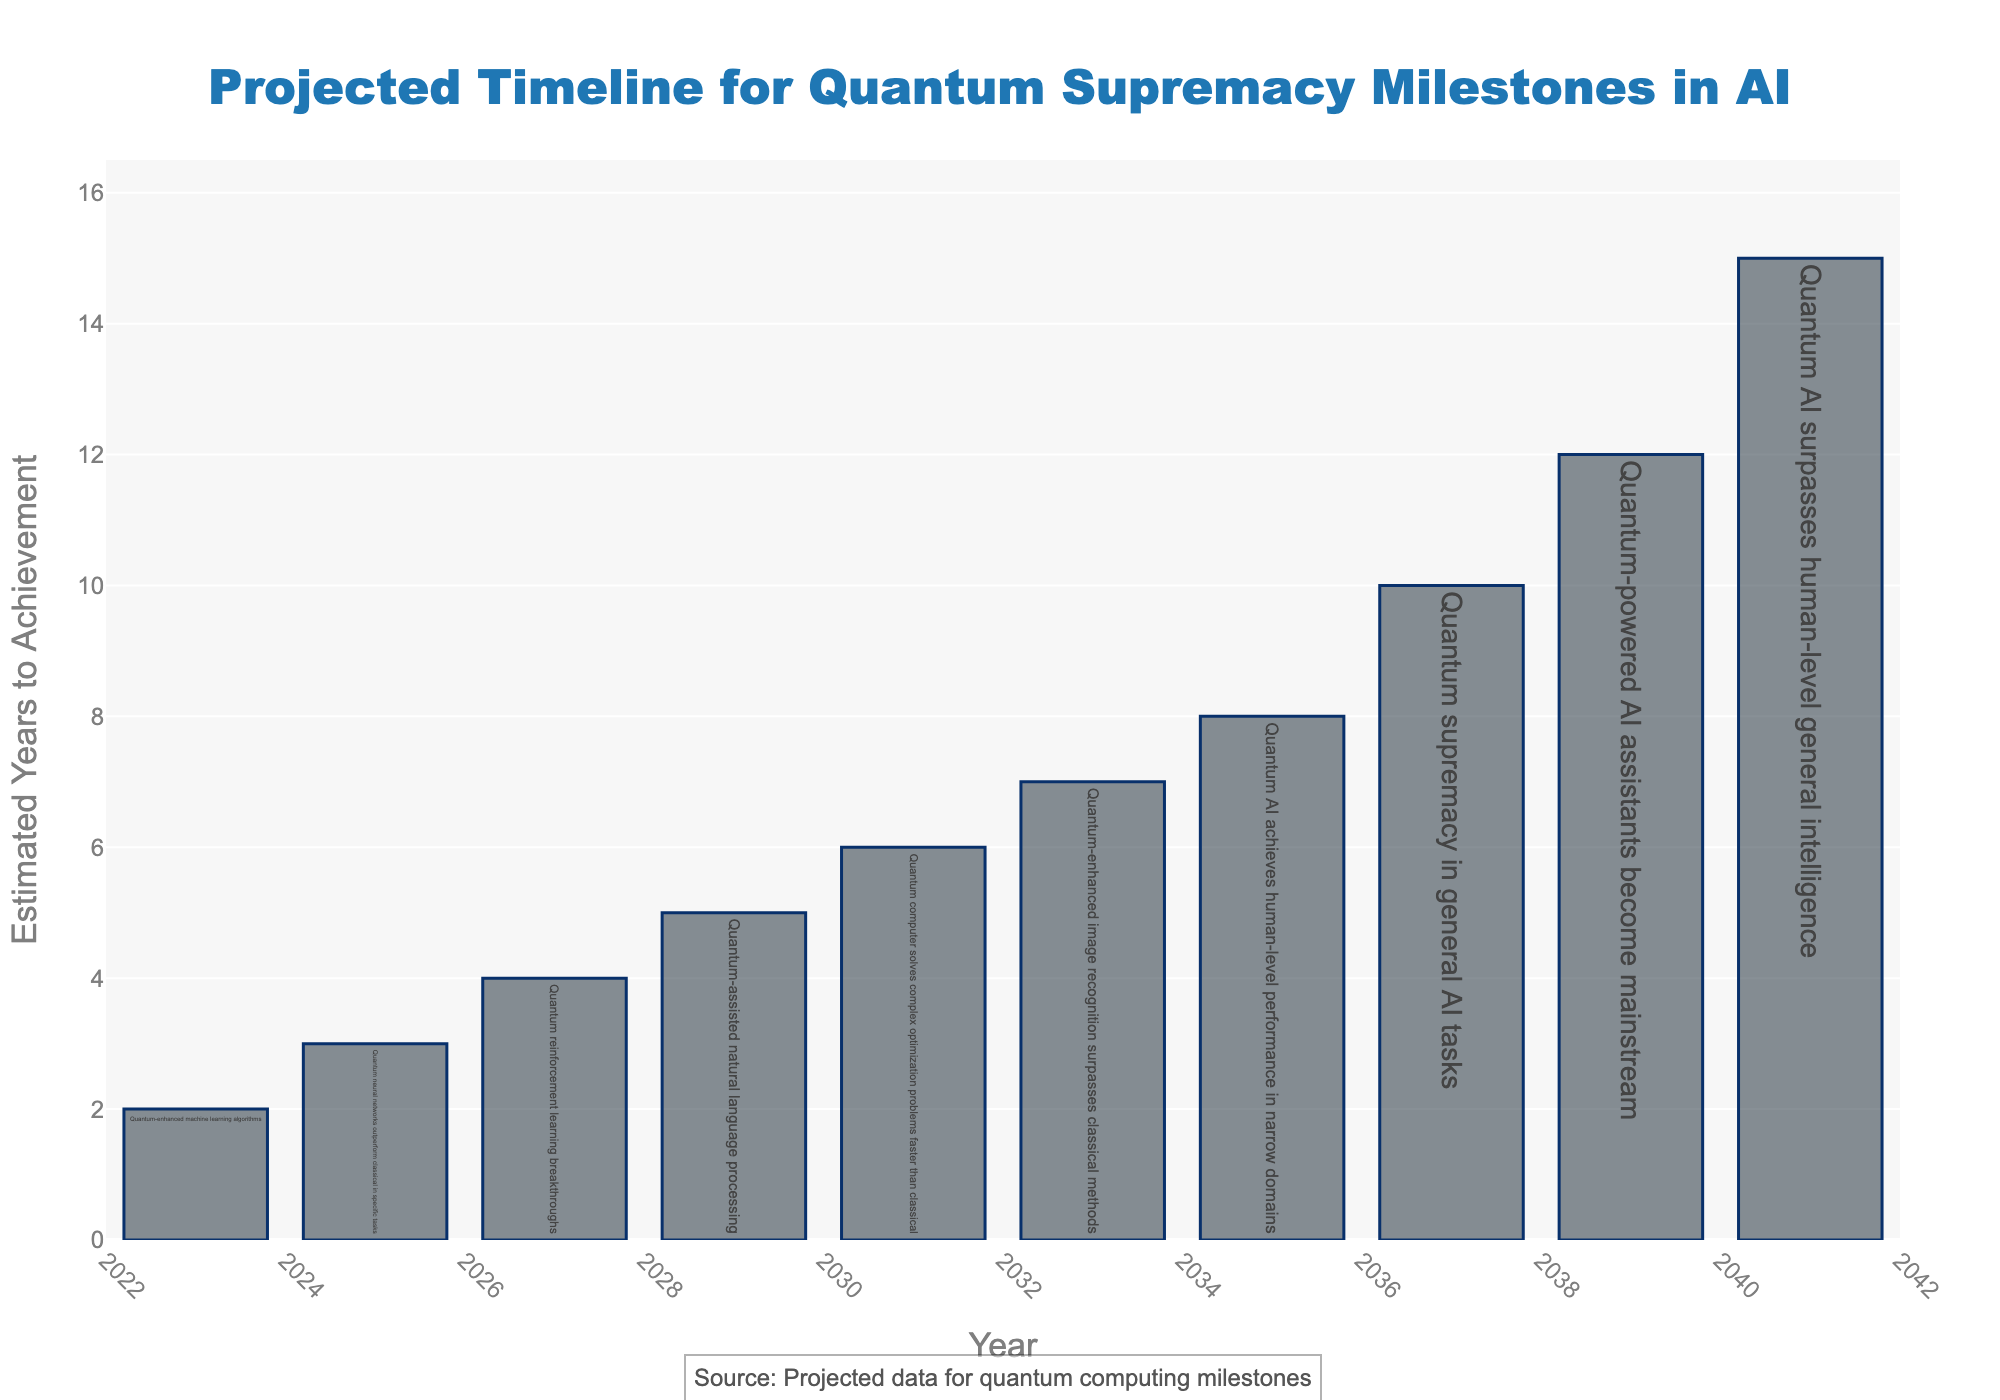What milestone is projected to be achieved by 2025? The bar corresponding to the year 2025 lists "Quantum neural networks outperform classical in specific tasks" as the milestone. This is confirmed by the hover text that provides detailed information.
Answer: Quantum neural networks outperform classical in specific tasks Which milestone takes the longest time to achieve from the start year? The bars represent different milestones, and the last one for the year 2041 lists "Quantum AI surpasses human-level general intelligence" with 15 estimated years. This is the highest number of years among all milestones.
Answer: Quantum AI surpasses human-level general intelligence What is the total estimated years to achievement for milestones projected between 2025 and 2031? To find the total, we add the estimated years for the milestones in 2025 (3 years), 2027 (4 years), and 2029 (5 years). This gives 3 + 4 + 5 = 12 years.
Answer: 12 years How does the estimated time to achieve "Quantum-enhanced image recognition surpasses classical methods" compare to "Quantum-assisted natural language processing"? The milestone for "Quantum-enhanced image recognition surpasses classical methods" is projected at 2033 with 7 years, while "Quantum-assisted natural language processing" is projected at 2029 with 5 years. 7 is greater than 5.
Answer: Quantum-enhanced image recognition takes 2 more years What is the average estimated years to achievement for milestones projected before 2030? The milestones before 2030 are 2023 (2 years), 2025 (3 years), 2027 (4 years), and 2029 (5 years). The average is calculated by (2 + 3 + 4 + 5) / 4 = 14 / 4 = 3.5 years.
Answer: 3.5 years Which milestone is projected to be reached within 2 years from 2023? The bar for the year 2023 shows "Quantum-enhanced machine learning algorithms" with an estimated 2 years, matching the criterion given.
Answer: Quantum-enhanced machine learning algorithms At what year is it projected that quantum-power AI assistants will become mainstream? The bar for the year 2039 corresponds to "Quantum-powered AI assistants become mainstream," with the hover text confirming this projection.
Answer: 2039 What is the difference in estimated years between achieving "Quantum AI achieves human-level performance in narrow domains" and "Quantum-enhanced image recognition surpasses classical methods"? "Quantum AI achieves human-level performance in narrow domains" is in 2035 (8 years) and "Quantum-enhanced image recognition surpasses classical methods" is in 2033 (7 years). The difference is 8 - 7 = 1 year.
Answer: 1 year What milestone is projected for 2031 and how long will it take? The bar for the year 2031 indicates "Quantum computer solves complex optimization problems faster than classical," with an estimated duration of 6 years mentioned in the hover text.
Answer: Quantum computer solves complex optimization problems faster than classical, 6 years 